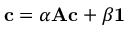<formula> <loc_0><loc_0><loc_500><loc_500>{ c } = \alpha { A } { c } + \beta { 1 }</formula> 